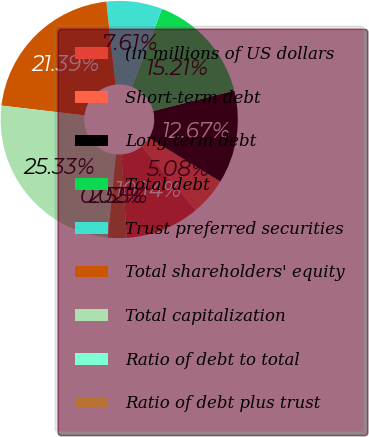Convert chart. <chart><loc_0><loc_0><loc_500><loc_500><pie_chart><fcel>(in millions of US dollars<fcel>Short-term debt<fcel>Long-term debt<fcel>Total debt<fcel>Trust preferred securities<fcel>Total shareholders' equity<fcel>Total capitalization<fcel>Ratio of debt to total<fcel>Ratio of debt plus trust<nl><fcel>10.14%<fcel>5.08%<fcel>12.67%<fcel>15.21%<fcel>7.61%<fcel>21.39%<fcel>25.33%<fcel>0.02%<fcel>2.55%<nl></chart> 